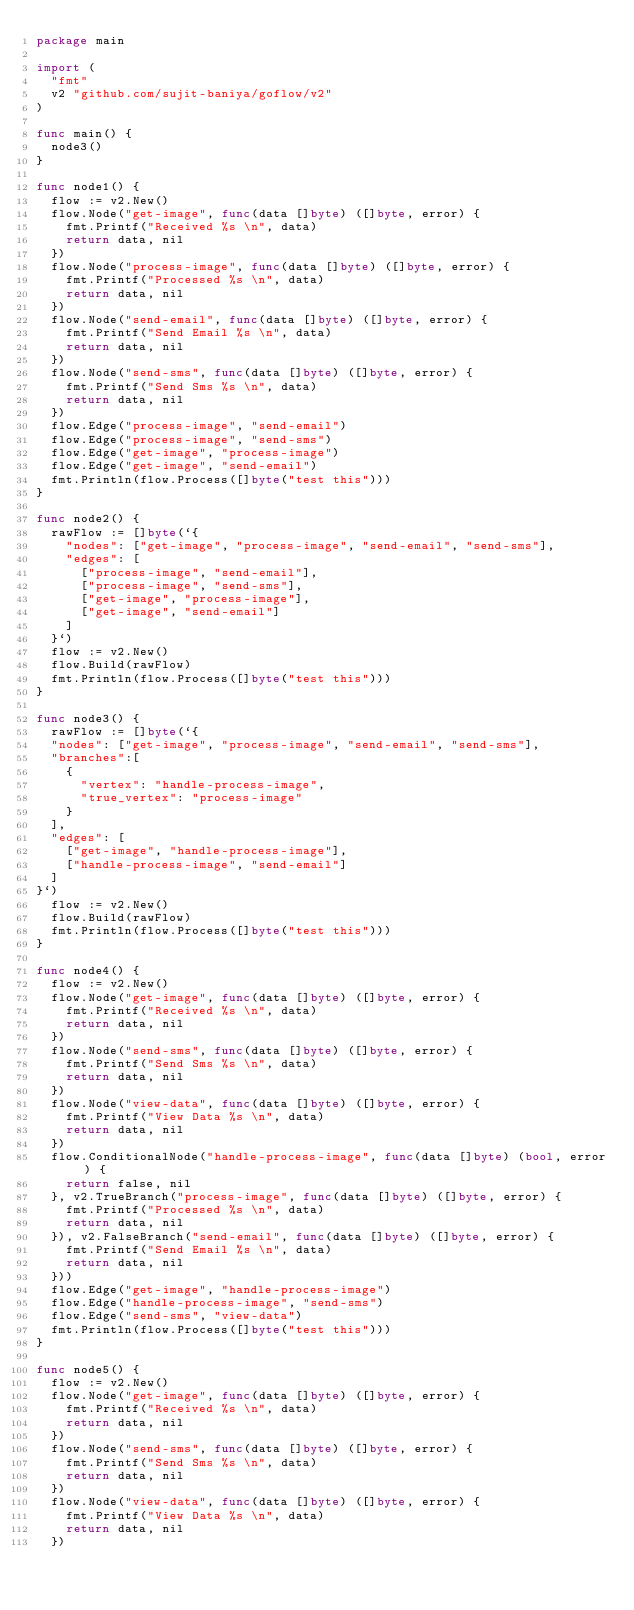<code> <loc_0><loc_0><loc_500><loc_500><_Go_>package main

import (
	"fmt"
	v2 "github.com/sujit-baniya/goflow/v2"
)

func main() {
	node3()
}

func node1() {
	flow := v2.New()
	flow.Node("get-image", func(data []byte) ([]byte, error) {
		fmt.Printf("Received %s \n", data)
		return data, nil
	})
	flow.Node("process-image", func(data []byte) ([]byte, error) {
		fmt.Printf("Processed %s \n", data)
		return data, nil
	})
	flow.Node("send-email", func(data []byte) ([]byte, error) {
		fmt.Printf("Send Email %s \n", data)
		return data, nil
	})
	flow.Node("send-sms", func(data []byte) ([]byte, error) {
		fmt.Printf("Send Sms %s \n", data)
		return data, nil
	})
	flow.Edge("process-image", "send-email")
	flow.Edge("process-image", "send-sms")
	flow.Edge("get-image", "process-image")
	flow.Edge("get-image", "send-email")
	fmt.Println(flow.Process([]byte("test this")))
}

func node2() {
	rawFlow := []byte(`{
		"nodes": ["get-image", "process-image", "send-email", "send-sms"],
		"edges": [
			["process-image", "send-email"], 
			["process-image", "send-sms"], 
			["get-image", "process-image"],
			["get-image", "send-email"]
		]
	}`)
	flow := v2.New()
	flow.Build(rawFlow)
	fmt.Println(flow.Process([]byte("test this")))
}

func node3() {
	rawFlow := []byte(`{
	"nodes": ["get-image", "process-image", "send-email", "send-sms"],
	"branches":[
		{
			"vertex": "handle-process-image",
			"true_vertex": "process-image"
		}
	],
	"edges": [
		["get-image", "handle-process-image"],
		["handle-process-image", "send-email"]
	]
}`)
	flow := v2.New()
	flow.Build(rawFlow)
	fmt.Println(flow.Process([]byte("test this")))
}

func node4() {
	flow := v2.New()
	flow.Node("get-image", func(data []byte) ([]byte, error) {
		fmt.Printf("Received %s \n", data)
		return data, nil
	})
	flow.Node("send-sms", func(data []byte) ([]byte, error) {
		fmt.Printf("Send Sms %s \n", data)
		return data, nil
	})
	flow.Node("view-data", func(data []byte) ([]byte, error) {
		fmt.Printf("View Data %s \n", data)
		return data, nil
	})
	flow.ConditionalNode("handle-process-image", func(data []byte) (bool, error) {
		return false, nil
	}, v2.TrueBranch("process-image", func(data []byte) ([]byte, error) {
		fmt.Printf("Processed %s \n", data)
		return data, nil
	}), v2.FalseBranch("send-email", func(data []byte) ([]byte, error) {
		fmt.Printf("Send Email %s \n", data)
		return data, nil
	}))
	flow.Edge("get-image", "handle-process-image")
	flow.Edge("handle-process-image", "send-sms")
	flow.Edge("send-sms", "view-data")
	fmt.Println(flow.Process([]byte("test this")))
}

func node5() {
	flow := v2.New()
	flow.Node("get-image", func(data []byte) ([]byte, error) {
		fmt.Printf("Received %s \n", data)
		return data, nil
	})
	flow.Node("send-sms", func(data []byte) ([]byte, error) {
		fmt.Printf("Send Sms %s \n", data)
		return data, nil
	})
	flow.Node("view-data", func(data []byte) ([]byte, error) {
		fmt.Printf("View Data %s \n", data)
		return data, nil
	})</code> 